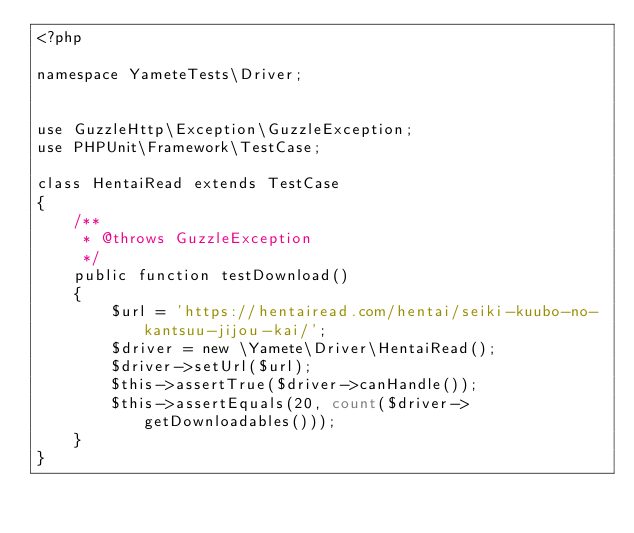Convert code to text. <code><loc_0><loc_0><loc_500><loc_500><_PHP_><?php

namespace YameteTests\Driver;


use GuzzleHttp\Exception\GuzzleException;
use PHPUnit\Framework\TestCase;

class HentaiRead extends TestCase
{
    /**
     * @throws GuzzleException
     */
    public function testDownload()
    {
        $url = 'https://hentairead.com/hentai/seiki-kuubo-no-kantsuu-jijou-kai/';
        $driver = new \Yamete\Driver\HentaiRead();
        $driver->setUrl($url);
        $this->assertTrue($driver->canHandle());
        $this->assertEquals(20, count($driver->getDownloadables()));
    }
}
</code> 